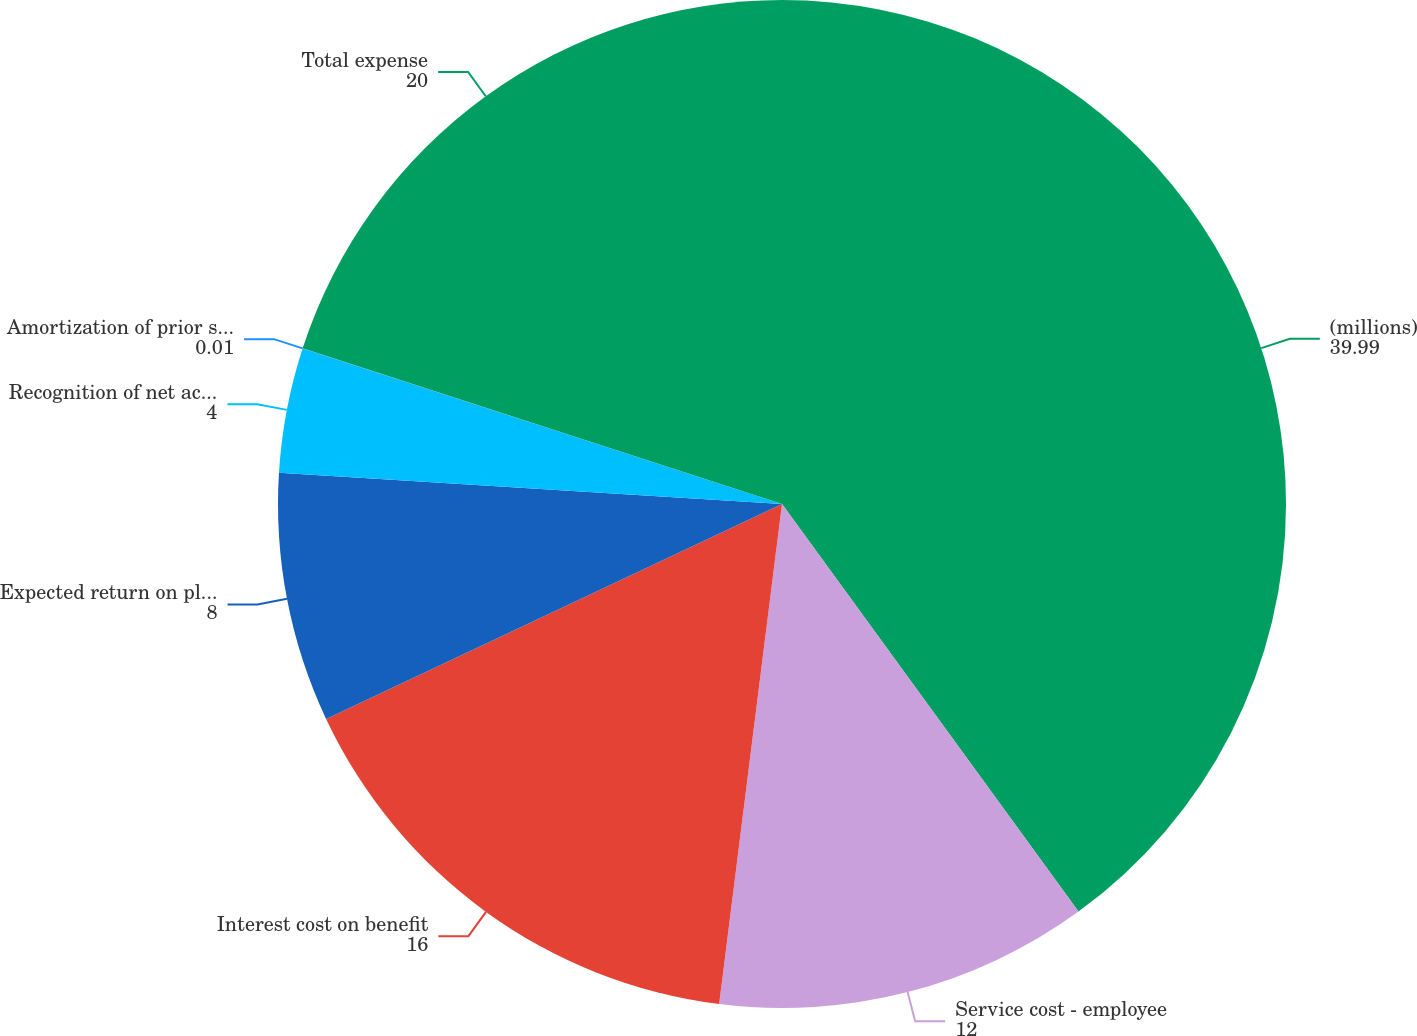Convert chart to OTSL. <chart><loc_0><loc_0><loc_500><loc_500><pie_chart><fcel>(millions)<fcel>Service cost - employee<fcel>Interest cost on benefit<fcel>Expected return on plan assets<fcel>Recognition of net actuarial<fcel>Amortization of prior service<fcel>Total expense<nl><fcel>39.99%<fcel>12.0%<fcel>16.0%<fcel>8.0%<fcel>4.0%<fcel>0.01%<fcel>20.0%<nl></chart> 